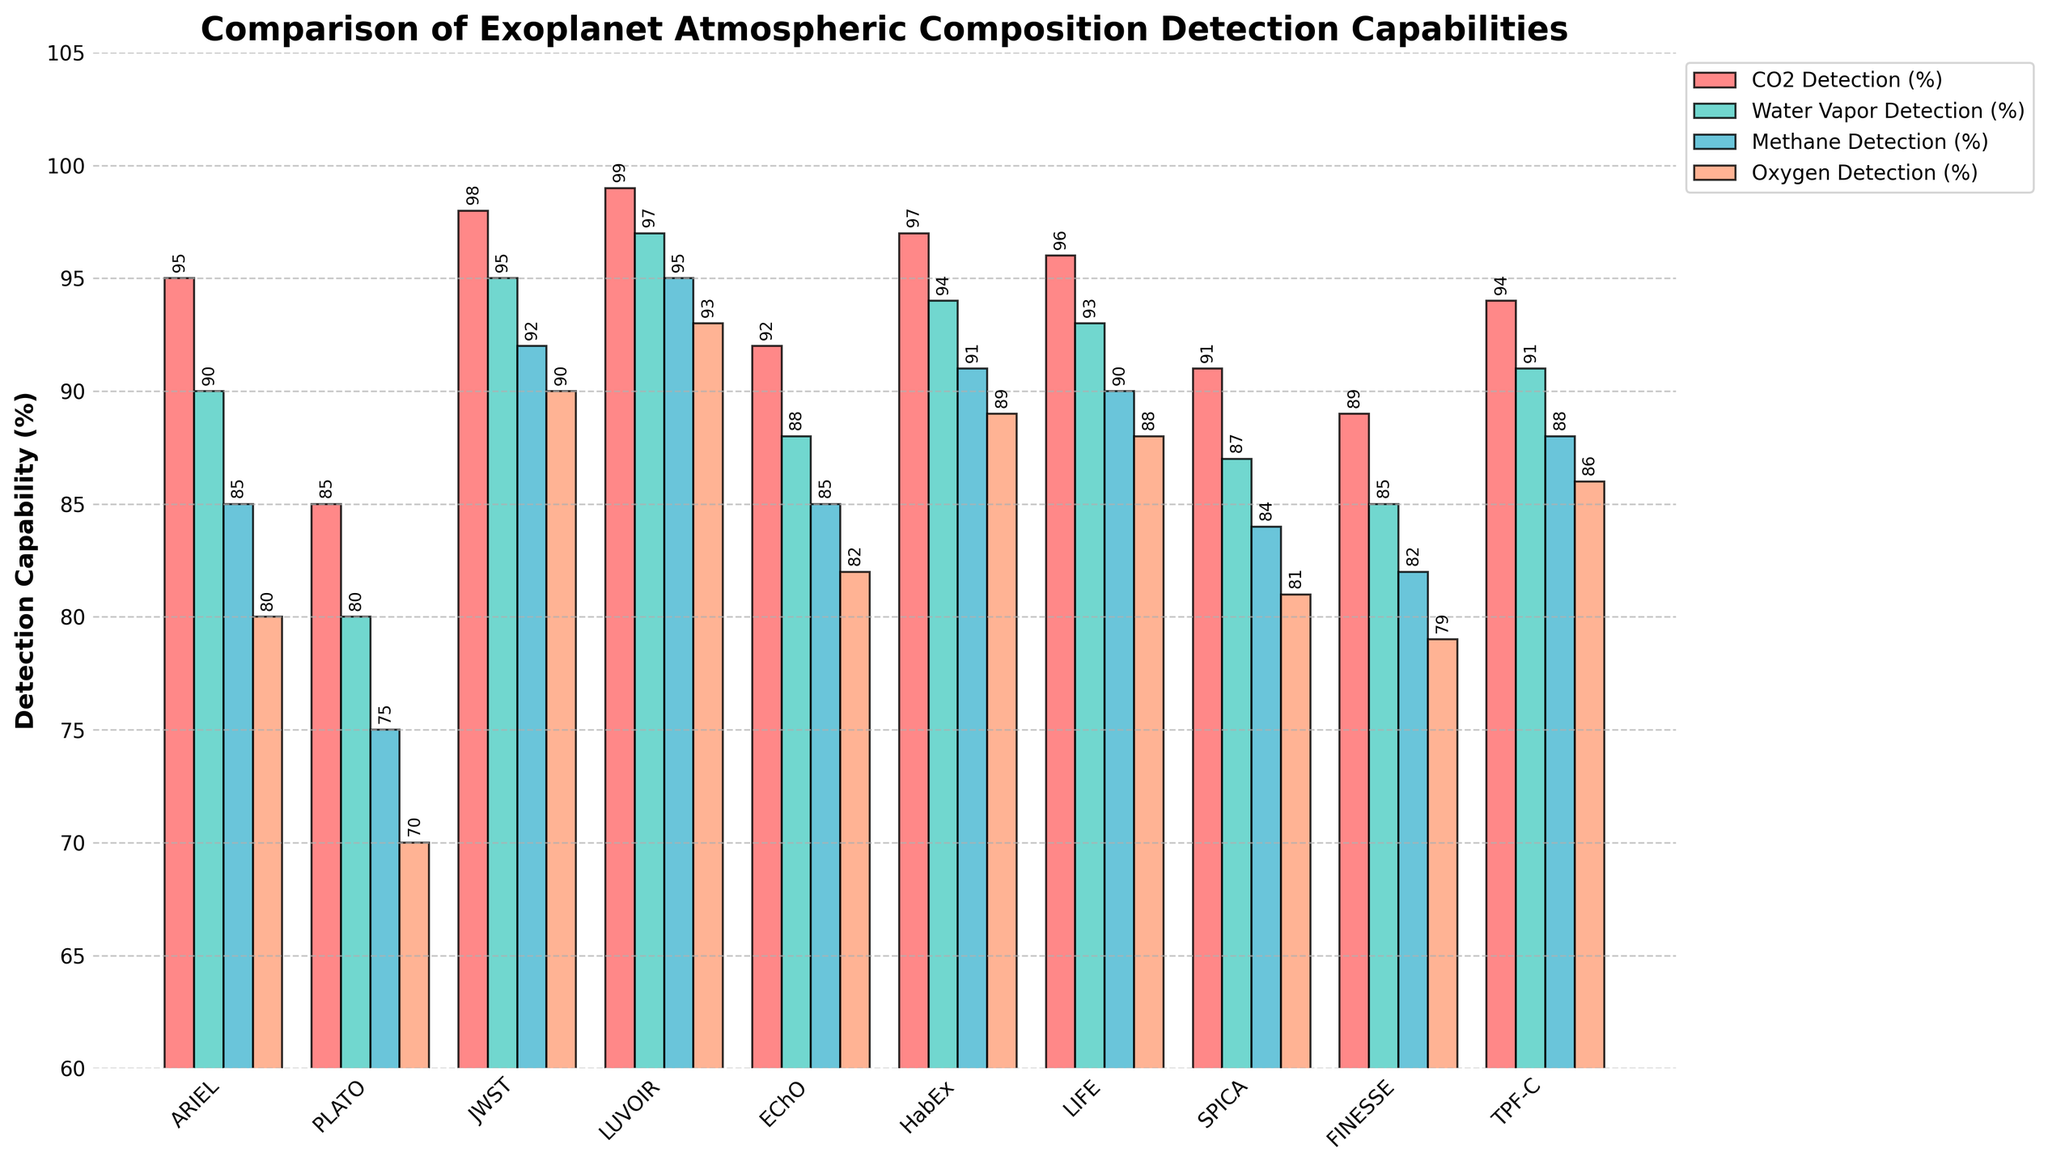What mission has the highest CO2 detection capability? By looking at the heights of the bars for CO2 detection, LUVOIR exhibits the highest value.
Answer: LUVOIR Which mission shows the lowest capability for detecting oxygen? Observing the bars for oxygen detection, PLATO has the shortest bar, indicating the lowest value.
Answer: PLATO What's the average detection capability for methane across all the missions? Add up all the methane detection percentages (85 + 75 + 92 + 95 + 85 + 91 + 90 + 84 + 82 + 88 = 867) and divide by the number of missions (10). 867 / 10 = 86.7.
Answer: 86.7% How does JWST's performance in water vapor detection compare to FINESSE? Compare the heights of the water vapor detection bars for both. JWST has a higher bar (95%) compared to FINESSE (85%).
Answer: JWST performs better Which mission has the most consistent performance across all categories? Consistency can be gauged by the least variation between different detection percentages for a mission. LUVOIR's detection capabilities are 99%, 97%, 95%, and 93%, which are very close to each other.
Answer: LUVOIR Summarize the detection capability range for EChO in all categories. Find the minimum and maximum detection capability % for EChO. They are 85% (methane) and 92% (CO2). Hence, the range is 92% - 85% = 7%.
Answer: 7% Which two missions have the most similar CO2 detection capabilities, and what are their values? Comparing the CO2 detection values, ARIEL (95%) and TPF-C (94%) are the closest.
Answer: ARIEL and TPF-C with 95% and 94% Identify the mission with the highest methane detection rate and the mission with the lowest water vapor detection rate. By examining the bars, LUVOIR exhibits the highest methane detection (95%), and PLATO shows the lowest water vapor detection (80%).
Answer: LUVOIR and PLATO Compare the detection capabilities of LIFE and HabEx for oxygen and state who performs better. Look at the oxygen detection bars: LIFE has 88% and HabEx has 89%. Thus, HabEx performs marginally better.
Answer: HabEx 